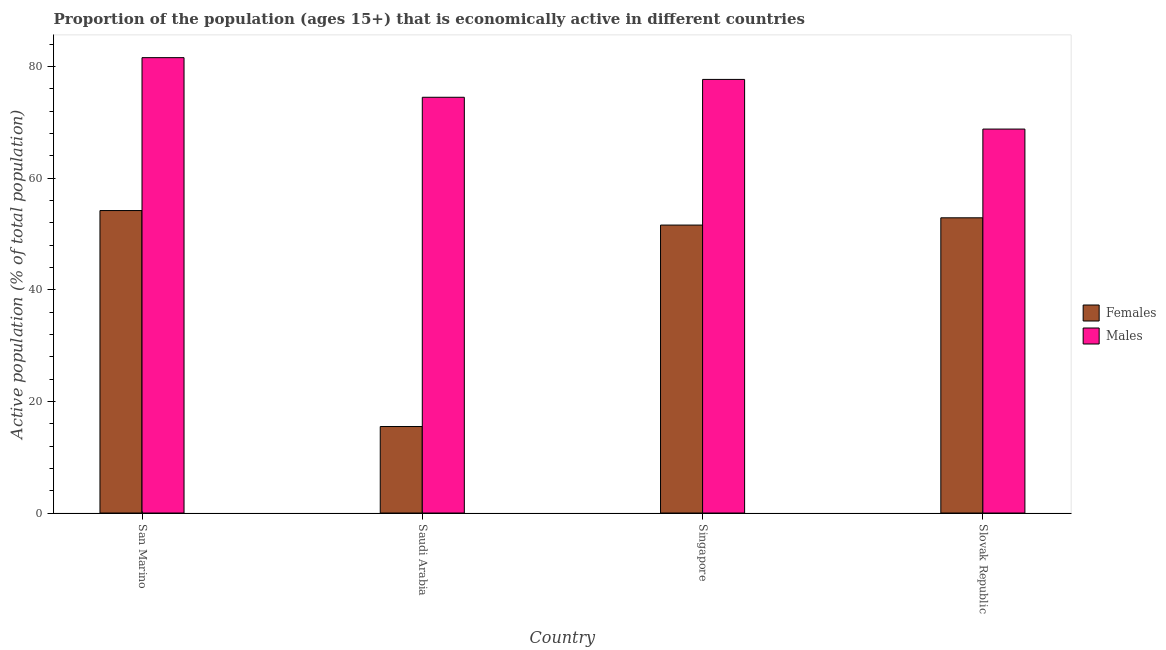How many different coloured bars are there?
Your response must be concise. 2. How many groups of bars are there?
Your answer should be very brief. 4. Are the number of bars per tick equal to the number of legend labels?
Keep it short and to the point. Yes. Are the number of bars on each tick of the X-axis equal?
Your answer should be very brief. Yes. What is the label of the 4th group of bars from the left?
Make the answer very short. Slovak Republic. What is the percentage of economically active female population in Singapore?
Your response must be concise. 51.6. Across all countries, what is the maximum percentage of economically active male population?
Ensure brevity in your answer.  81.6. Across all countries, what is the minimum percentage of economically active male population?
Ensure brevity in your answer.  68.8. In which country was the percentage of economically active female population maximum?
Your answer should be compact. San Marino. In which country was the percentage of economically active male population minimum?
Give a very brief answer. Slovak Republic. What is the total percentage of economically active male population in the graph?
Ensure brevity in your answer.  302.6. What is the difference between the percentage of economically active male population in Saudi Arabia and that in Singapore?
Provide a succinct answer. -3.2. What is the difference between the percentage of economically active male population in Singapore and the percentage of economically active female population in Saudi Arabia?
Make the answer very short. 62.2. What is the average percentage of economically active male population per country?
Your answer should be compact. 75.65. What is the difference between the percentage of economically active female population and percentage of economically active male population in San Marino?
Make the answer very short. -27.4. What is the ratio of the percentage of economically active male population in San Marino to that in Saudi Arabia?
Your answer should be compact. 1.1. What is the difference between the highest and the second highest percentage of economically active female population?
Your answer should be very brief. 1.3. What is the difference between the highest and the lowest percentage of economically active female population?
Offer a terse response. 38.7. Is the sum of the percentage of economically active female population in San Marino and Slovak Republic greater than the maximum percentage of economically active male population across all countries?
Provide a short and direct response. Yes. What does the 2nd bar from the left in Singapore represents?
Offer a terse response. Males. What does the 1st bar from the right in Singapore represents?
Provide a succinct answer. Males. How many bars are there?
Offer a terse response. 8. Are all the bars in the graph horizontal?
Make the answer very short. No. What is the difference between two consecutive major ticks on the Y-axis?
Offer a terse response. 20. Does the graph contain any zero values?
Your answer should be compact. No. Where does the legend appear in the graph?
Offer a terse response. Center right. How many legend labels are there?
Provide a short and direct response. 2. What is the title of the graph?
Your answer should be compact. Proportion of the population (ages 15+) that is economically active in different countries. Does "RDB nonconcessional" appear as one of the legend labels in the graph?
Your answer should be compact. No. What is the label or title of the X-axis?
Offer a terse response. Country. What is the label or title of the Y-axis?
Give a very brief answer. Active population (% of total population). What is the Active population (% of total population) of Females in San Marino?
Provide a succinct answer. 54.2. What is the Active population (% of total population) of Males in San Marino?
Your response must be concise. 81.6. What is the Active population (% of total population) in Males in Saudi Arabia?
Give a very brief answer. 74.5. What is the Active population (% of total population) of Females in Singapore?
Your answer should be compact. 51.6. What is the Active population (% of total population) of Males in Singapore?
Make the answer very short. 77.7. What is the Active population (% of total population) in Females in Slovak Republic?
Your response must be concise. 52.9. What is the Active population (% of total population) in Males in Slovak Republic?
Offer a terse response. 68.8. Across all countries, what is the maximum Active population (% of total population) in Females?
Keep it short and to the point. 54.2. Across all countries, what is the maximum Active population (% of total population) in Males?
Provide a succinct answer. 81.6. Across all countries, what is the minimum Active population (% of total population) of Females?
Ensure brevity in your answer.  15.5. Across all countries, what is the minimum Active population (% of total population) in Males?
Give a very brief answer. 68.8. What is the total Active population (% of total population) of Females in the graph?
Provide a short and direct response. 174.2. What is the total Active population (% of total population) in Males in the graph?
Ensure brevity in your answer.  302.6. What is the difference between the Active population (% of total population) in Females in San Marino and that in Saudi Arabia?
Keep it short and to the point. 38.7. What is the difference between the Active population (% of total population) in Males in San Marino and that in Saudi Arabia?
Keep it short and to the point. 7.1. What is the difference between the Active population (% of total population) in Males in San Marino and that in Singapore?
Keep it short and to the point. 3.9. What is the difference between the Active population (% of total population) in Females in San Marino and that in Slovak Republic?
Ensure brevity in your answer.  1.3. What is the difference between the Active population (% of total population) in Females in Saudi Arabia and that in Singapore?
Your answer should be very brief. -36.1. What is the difference between the Active population (% of total population) of Males in Saudi Arabia and that in Singapore?
Make the answer very short. -3.2. What is the difference between the Active population (% of total population) of Females in Saudi Arabia and that in Slovak Republic?
Keep it short and to the point. -37.4. What is the difference between the Active population (% of total population) of Females in San Marino and the Active population (% of total population) of Males in Saudi Arabia?
Provide a succinct answer. -20.3. What is the difference between the Active population (% of total population) in Females in San Marino and the Active population (% of total population) in Males in Singapore?
Your answer should be very brief. -23.5. What is the difference between the Active population (% of total population) in Females in San Marino and the Active population (% of total population) in Males in Slovak Republic?
Provide a succinct answer. -14.6. What is the difference between the Active population (% of total population) in Females in Saudi Arabia and the Active population (% of total population) in Males in Singapore?
Make the answer very short. -62.2. What is the difference between the Active population (% of total population) in Females in Saudi Arabia and the Active population (% of total population) in Males in Slovak Republic?
Offer a terse response. -53.3. What is the difference between the Active population (% of total population) of Females in Singapore and the Active population (% of total population) of Males in Slovak Republic?
Make the answer very short. -17.2. What is the average Active population (% of total population) in Females per country?
Ensure brevity in your answer.  43.55. What is the average Active population (% of total population) in Males per country?
Give a very brief answer. 75.65. What is the difference between the Active population (% of total population) of Females and Active population (% of total population) of Males in San Marino?
Give a very brief answer. -27.4. What is the difference between the Active population (% of total population) of Females and Active population (% of total population) of Males in Saudi Arabia?
Provide a short and direct response. -59. What is the difference between the Active population (% of total population) in Females and Active population (% of total population) in Males in Singapore?
Make the answer very short. -26.1. What is the difference between the Active population (% of total population) of Females and Active population (% of total population) of Males in Slovak Republic?
Offer a very short reply. -15.9. What is the ratio of the Active population (% of total population) of Females in San Marino to that in Saudi Arabia?
Provide a succinct answer. 3.5. What is the ratio of the Active population (% of total population) in Males in San Marino to that in Saudi Arabia?
Your answer should be very brief. 1.1. What is the ratio of the Active population (% of total population) in Females in San Marino to that in Singapore?
Your answer should be compact. 1.05. What is the ratio of the Active population (% of total population) in Males in San Marino to that in Singapore?
Provide a succinct answer. 1.05. What is the ratio of the Active population (% of total population) of Females in San Marino to that in Slovak Republic?
Provide a short and direct response. 1.02. What is the ratio of the Active population (% of total population) of Males in San Marino to that in Slovak Republic?
Offer a very short reply. 1.19. What is the ratio of the Active population (% of total population) in Females in Saudi Arabia to that in Singapore?
Your response must be concise. 0.3. What is the ratio of the Active population (% of total population) in Males in Saudi Arabia to that in Singapore?
Ensure brevity in your answer.  0.96. What is the ratio of the Active population (% of total population) of Females in Saudi Arabia to that in Slovak Republic?
Your answer should be very brief. 0.29. What is the ratio of the Active population (% of total population) in Males in Saudi Arabia to that in Slovak Republic?
Ensure brevity in your answer.  1.08. What is the ratio of the Active population (% of total population) in Females in Singapore to that in Slovak Republic?
Your response must be concise. 0.98. What is the ratio of the Active population (% of total population) of Males in Singapore to that in Slovak Republic?
Give a very brief answer. 1.13. What is the difference between the highest and the second highest Active population (% of total population) in Females?
Make the answer very short. 1.3. What is the difference between the highest and the second highest Active population (% of total population) of Males?
Provide a short and direct response. 3.9. What is the difference between the highest and the lowest Active population (% of total population) in Females?
Offer a terse response. 38.7. 